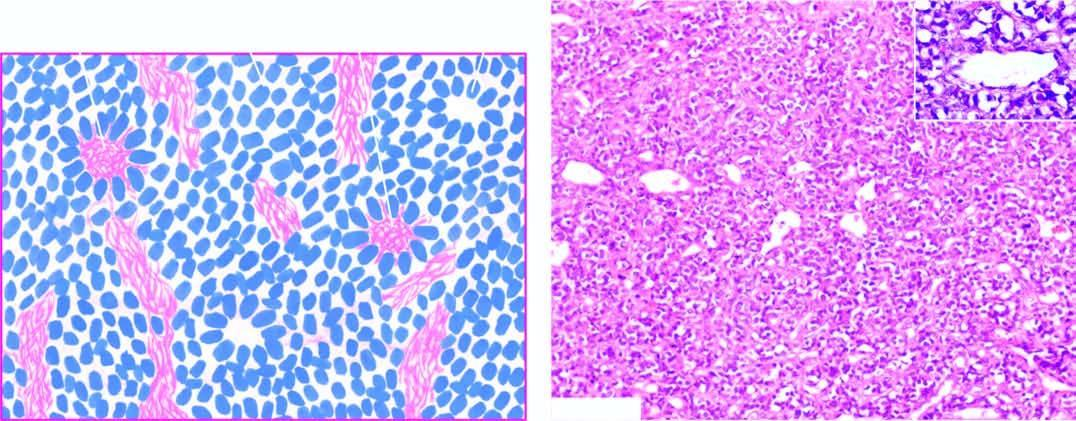does the incised wound as well as suture track on either side show a close-up view of pseudorosette?
Answer the question using a single word or phrase. No 